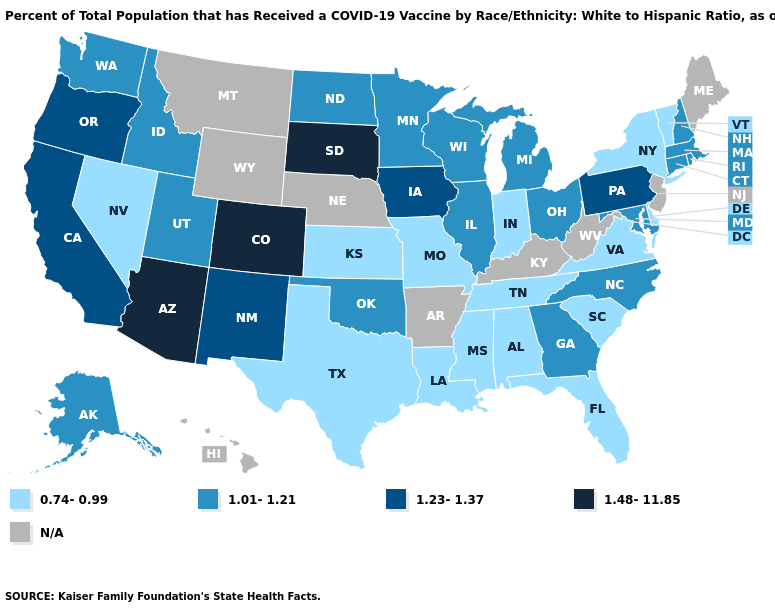What is the highest value in states that border New York?
Keep it brief. 1.23-1.37. Name the states that have a value in the range 1.01-1.21?
Concise answer only. Alaska, Connecticut, Georgia, Idaho, Illinois, Maryland, Massachusetts, Michigan, Minnesota, New Hampshire, North Carolina, North Dakota, Ohio, Oklahoma, Rhode Island, Utah, Washington, Wisconsin. Among the states that border Virginia , does North Carolina have the lowest value?
Be succinct. No. Does South Dakota have the highest value in the MidWest?
Keep it brief. Yes. Among the states that border Iowa , which have the highest value?
Write a very short answer. South Dakota. What is the value of Tennessee?
Concise answer only. 0.74-0.99. What is the value of Kentucky?
Keep it brief. N/A. What is the value of Oklahoma?
Short answer required. 1.01-1.21. Among the states that border North Carolina , which have the lowest value?
Keep it brief. South Carolina, Tennessee, Virginia. Name the states that have a value in the range 0.74-0.99?
Quick response, please. Alabama, Delaware, Florida, Indiana, Kansas, Louisiana, Mississippi, Missouri, Nevada, New York, South Carolina, Tennessee, Texas, Vermont, Virginia. What is the value of Arkansas?
Short answer required. N/A. Name the states that have a value in the range 1.23-1.37?
Quick response, please. California, Iowa, New Mexico, Oregon, Pennsylvania. What is the highest value in the USA?
Write a very short answer. 1.48-11.85. 